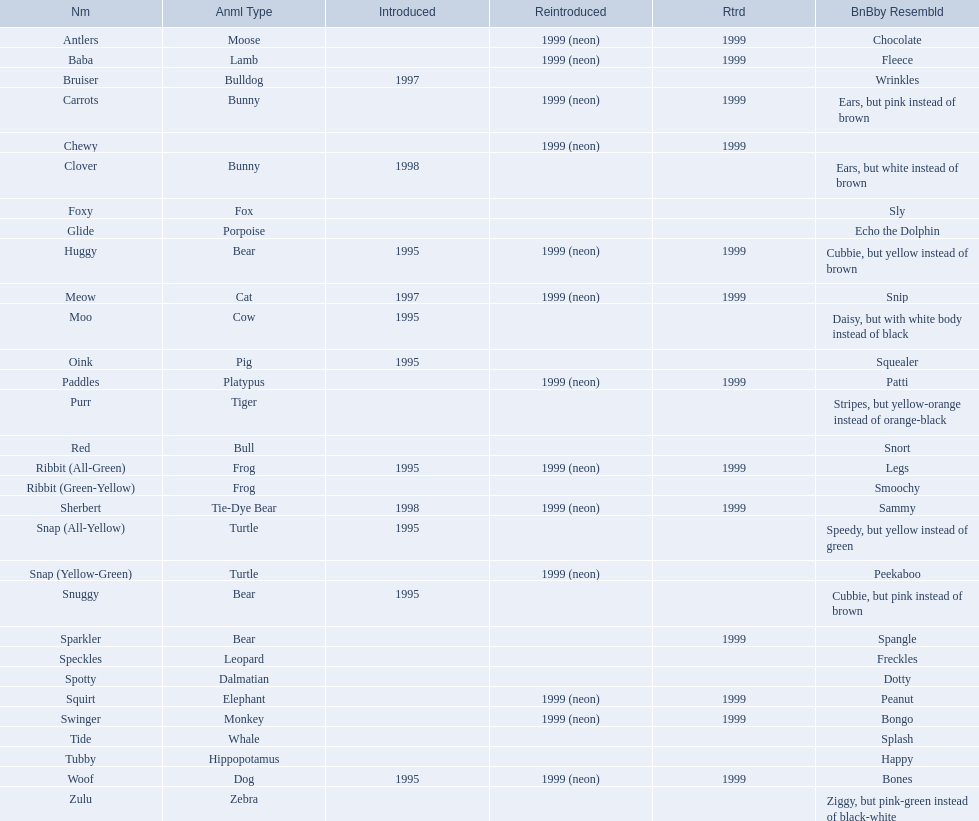What are the names listed? Antlers, Baba, Bruiser, Carrots, Chewy, Clover, Foxy, Glide, Huggy, Meow, Moo, Oink, Paddles, Purr, Red, Ribbit (All-Green), Ribbit (Green-Yellow), Sherbert, Snap (All-Yellow), Snap (Yellow-Green), Snuggy, Sparkler, Speckles, Spotty, Squirt, Swinger, Tide, Tubby, Woof, Zulu. Of these, which is the only pet without an animal type listed? Chewy. 